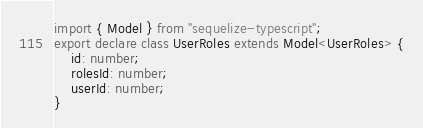<code> <loc_0><loc_0><loc_500><loc_500><_TypeScript_>import { Model } from "sequelize-typescript";
export declare class UserRoles extends Model<UserRoles> {
    id: number;
    rolesId: number;
    userId: number;
}
</code> 